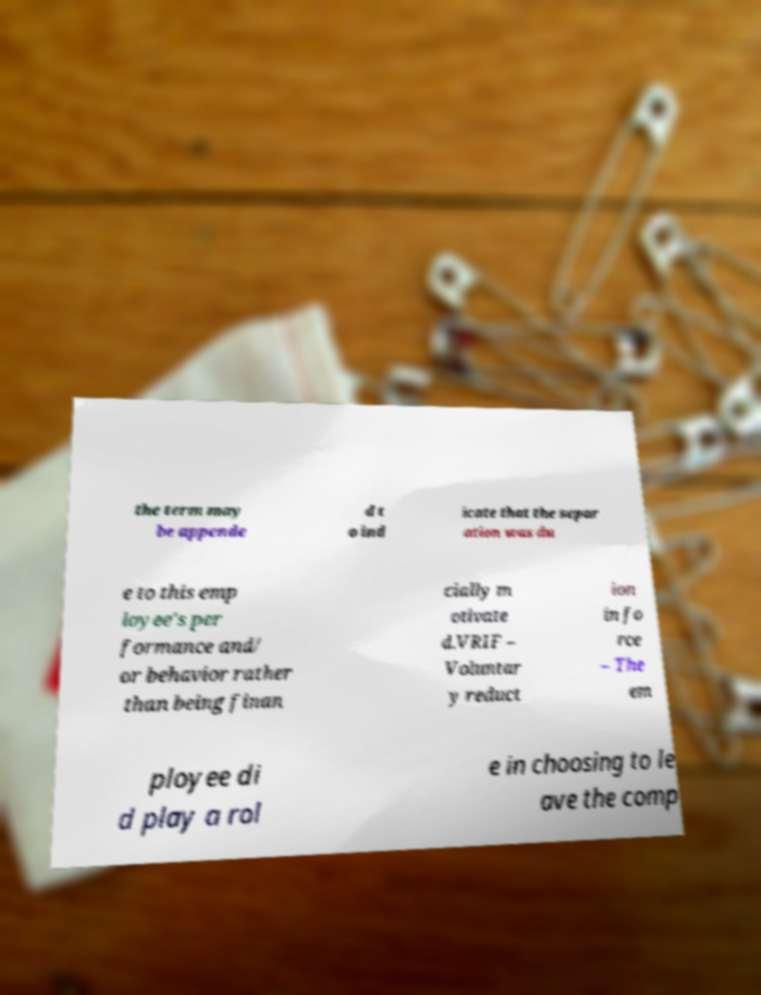Please identify and transcribe the text found in this image. the term may be appende d t o ind icate that the separ ation was du e to this emp loyee's per formance and/ or behavior rather than being finan cially m otivate d.VRIF – Voluntar y reduct ion in fo rce – The em ployee di d play a rol e in choosing to le ave the comp 